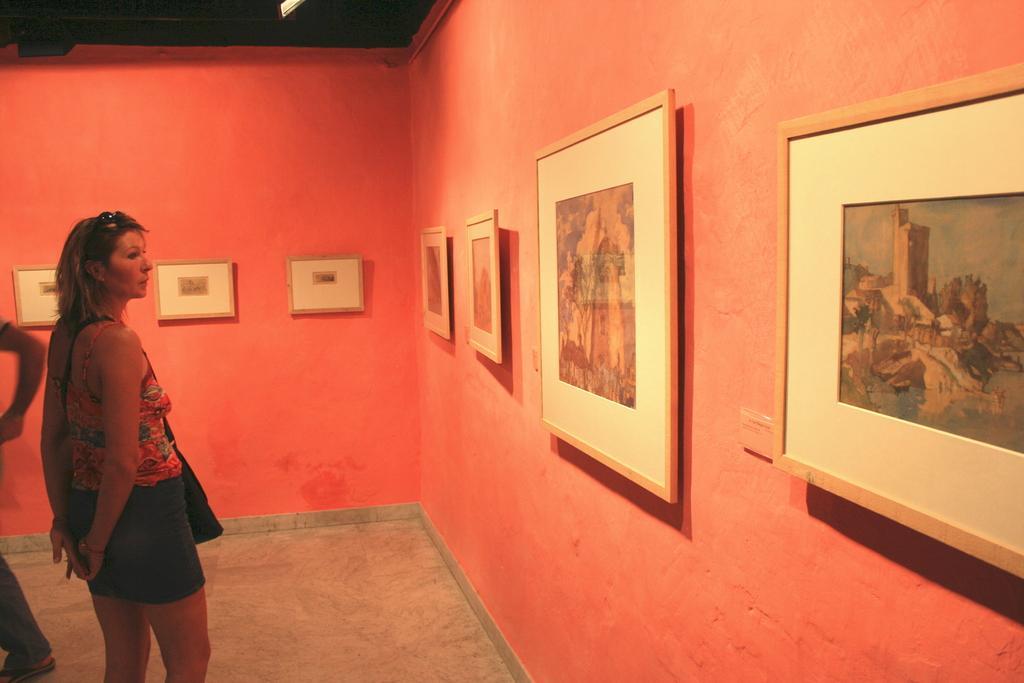In one or two sentences, can you explain what this image depicts? In the picture there is a woman standing, there are many frames present on the wall, beside the woman there is a person. 